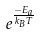<formula> <loc_0><loc_0><loc_500><loc_500>e ^ { \frac { - E _ { a } } { k _ { B } T } }</formula> 